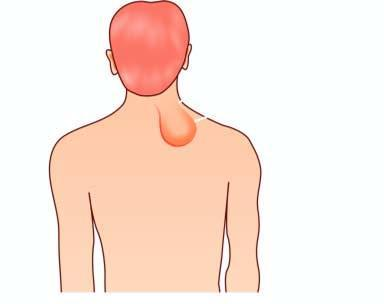s the nuclei of affected tubules soft, lobulated, yellowish and greasy?
Answer the question using a single word or phrase. No 